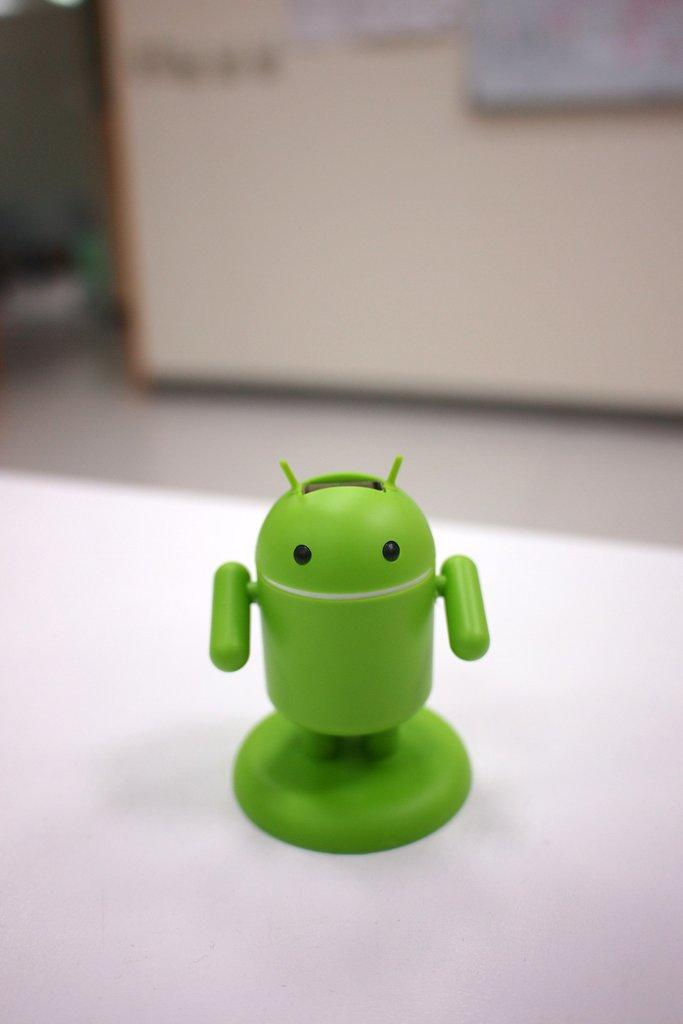What is the main object in the image? There is a green-colored Android logo toy in the image. Where is the toy placed? The toy is kept on a table. What can be seen on the wall in the image? There are banners on the wall in the image. How would you describe the background of the image? The background of the image is slightly blurred. What type of friction can be observed between the toy and the table in the image? There is no indication of friction between the toy and the table in the image. Is there a mine visible in the image? No, there is no mine present in the image. 